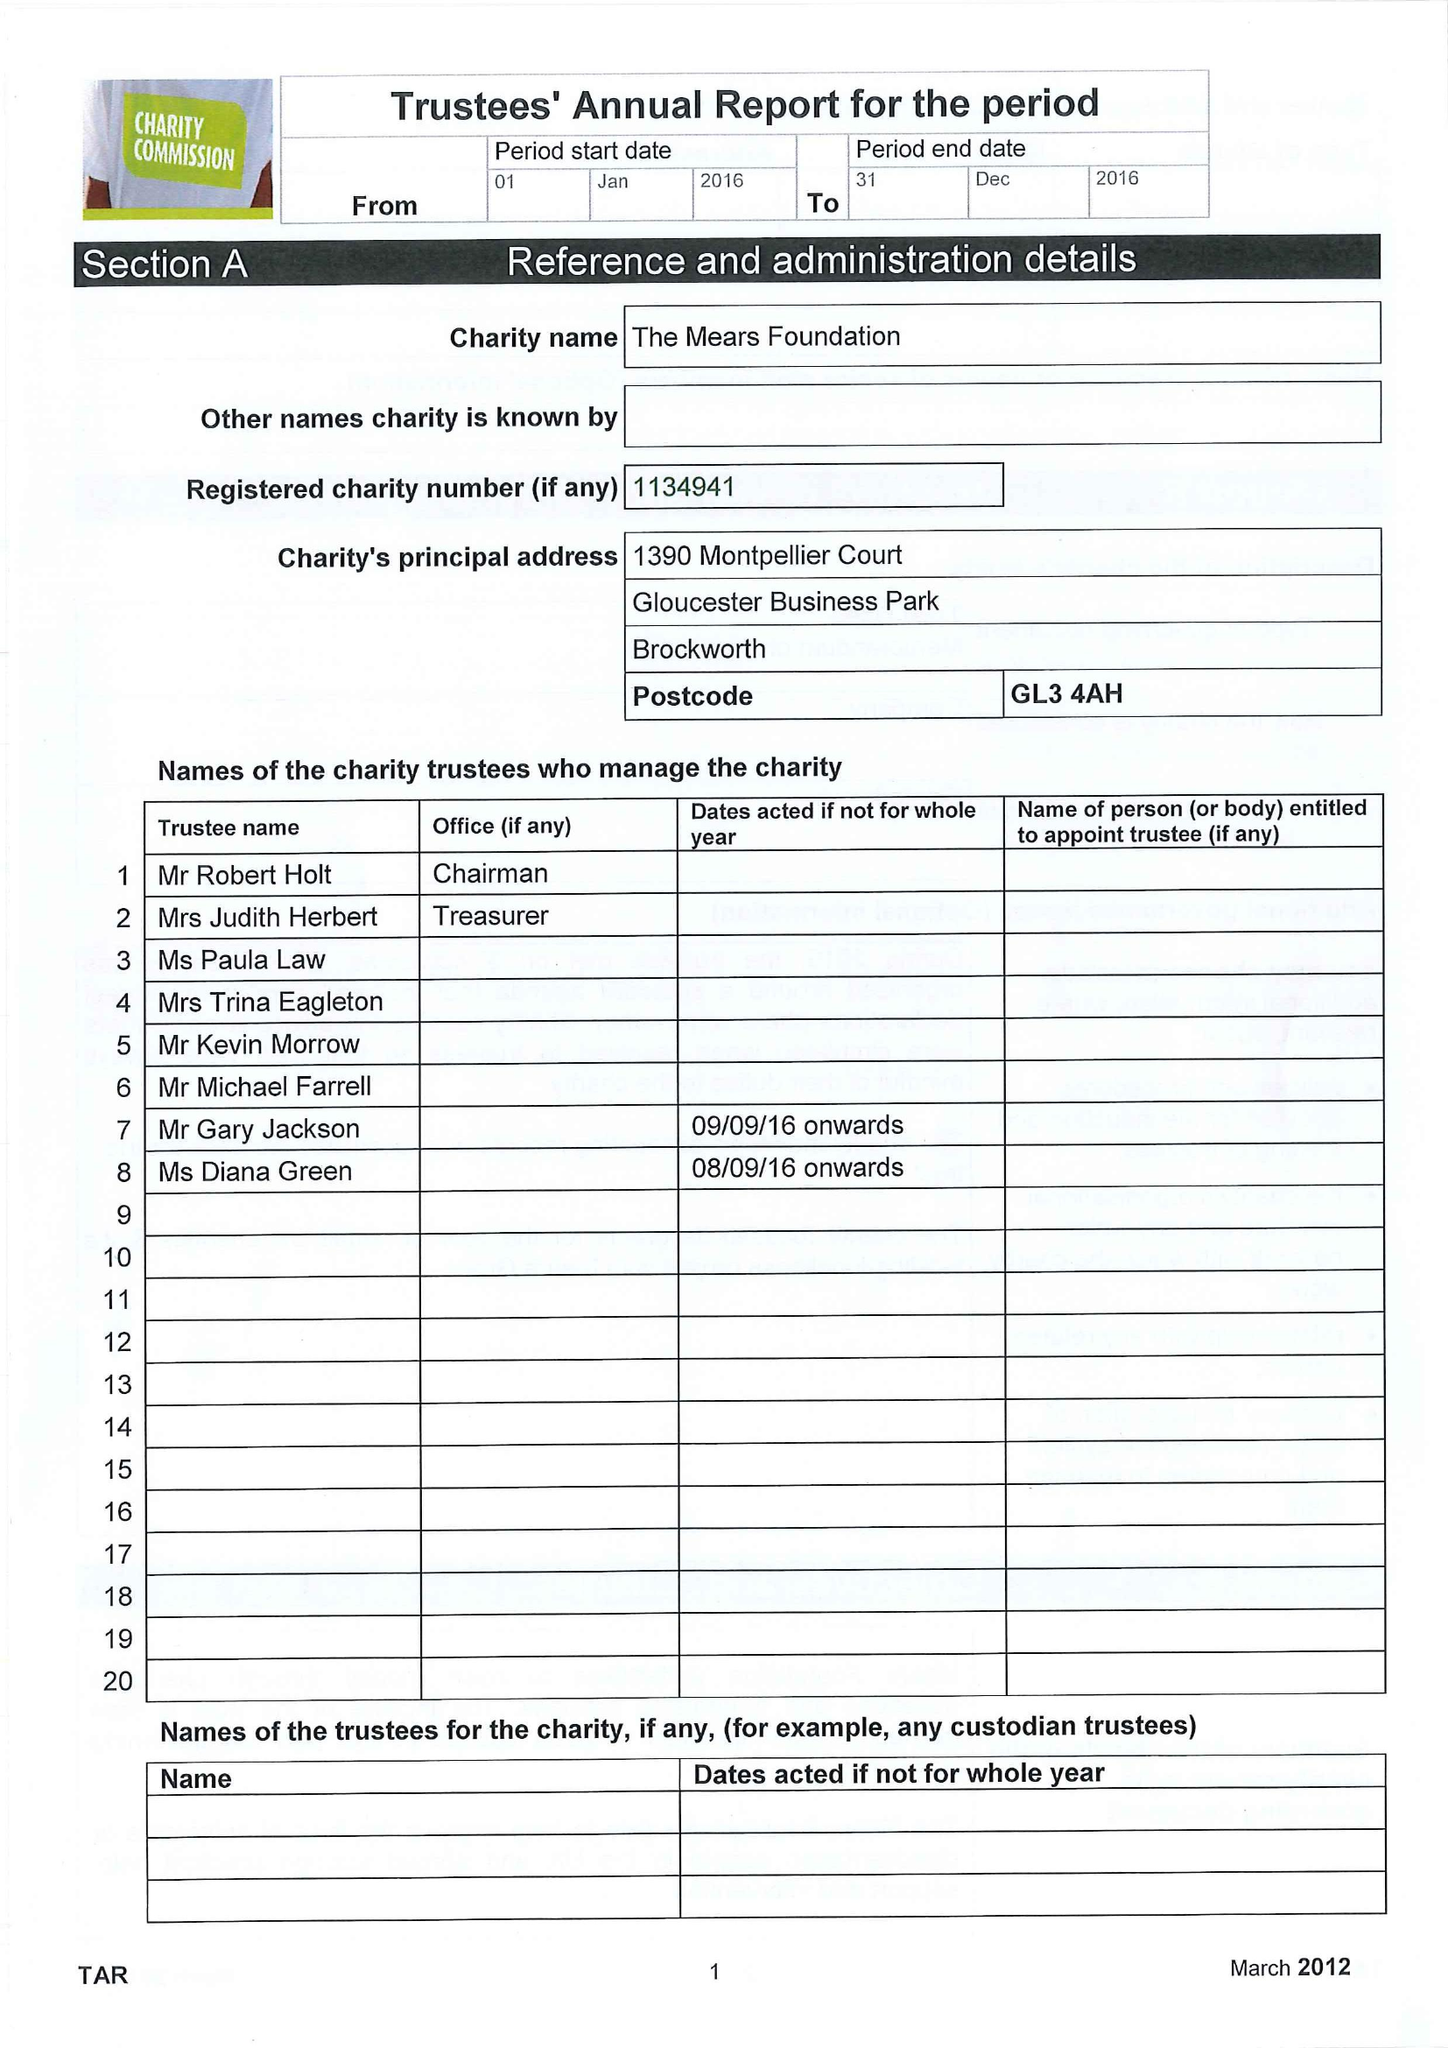What is the value for the income_annually_in_british_pounds?
Answer the question using a single word or phrase. 29758.00 